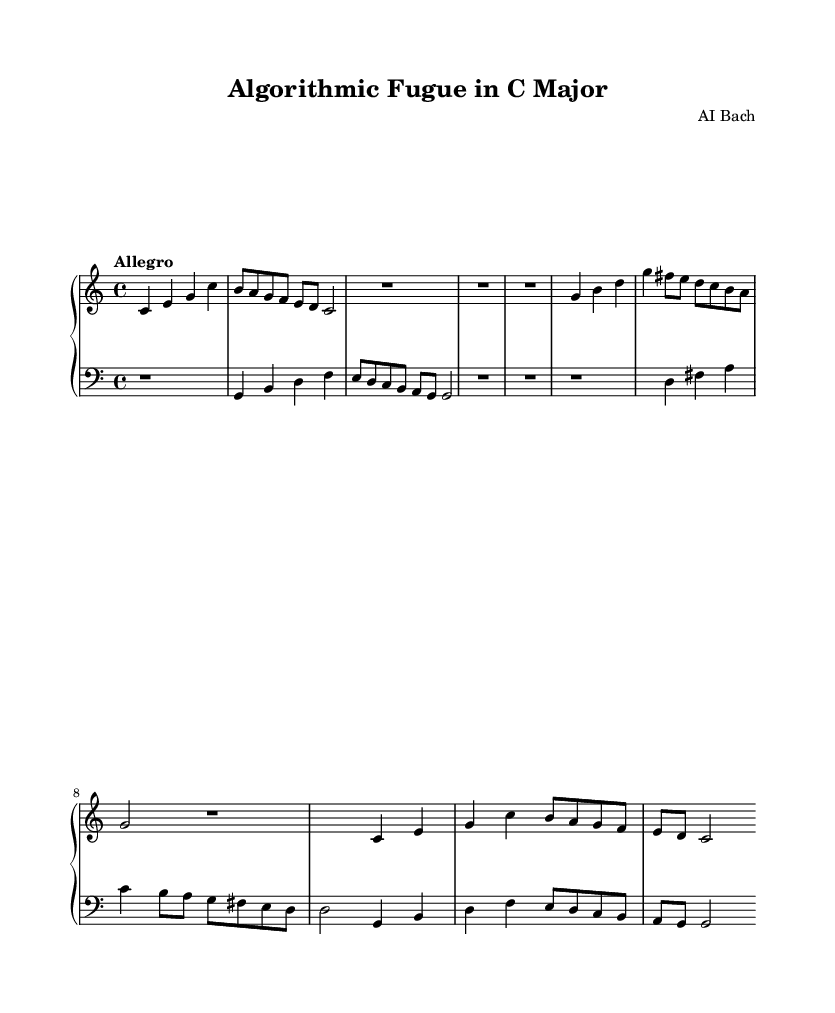What is the key signature of this music? The key signature is C major, which has no sharps or flats, indicated at the beginning of the score.
Answer: C major What is the time signature of this piece? The time signature of the piece is indicated at the beginning as 4/4, meaning there are four beats in a measure and a quarter note receives one beat.
Answer: 4/4 What is the tempo marking for the composition? The tempo marking "Allegro" suggests a fast and lively pace, and it is stated above the staff.
Answer: Allegro How many measures are in the exposition of the upper part? By analyzing the upper part, the exposition consists of five measures of music, including rests and the repeated subject.
Answer: 5 Which voice plays the countersubject in the lower part? The countersubject is played in the bass clef, below the treble clef in the lower staff, and consists of distinct notes that complement the subject.
Answer: Bass What type of form is predominantly used in this composition? The structure of the piece indicates it follows a fugue form, characterized by the use of subjects and countersubjects in various sections.
Answer: Fugue In which section does the development occur? The development section occurs after the exposition and is characterized by the transposition of the subject and countersubject to a different pitch, marked clearly in the sheet music.
Answer: Development 